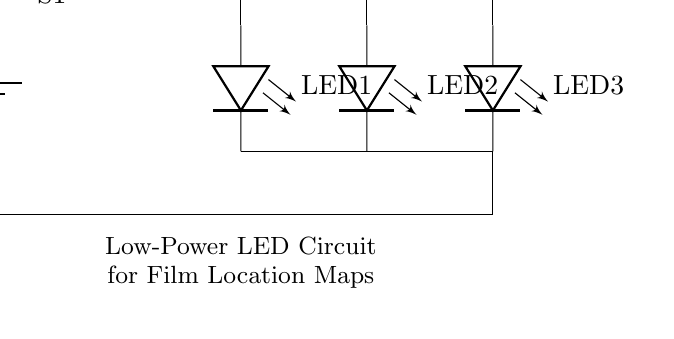What is the voltage of this circuit? The circuit is powered by a battery labeled as 3V, which indicates the potential difference supplied to the entire circuit.
Answer: 3V What is the purpose of the resistor in the circuit? The resistor, noted as 220 Ohms, is used to limit the current flowing through the LEDs, preventing them from burning out due to excessive current.
Answer: Current limiting How many LEDs are in this circuit? The diagram shows three LEDs labeled LED1, LED2, and LED3, indicating the total number of LEDs in the circuit.
Answer: Three What is the function of switch S1? Switch S1 allows the user to control the power to the circuit, turning it on or off, effectively managing the operation of the LEDs based on the switch's position.
Answer: Control power Which component connects all LEDs to ground? The ground connection is established through a line that connects the bottom terminals of the LEDs and ultimately connects to the battery's negative terminal, completing the circuit.
Answer: Ground connection What is the circuit type shown? The circuit is classified as a low-power LED lighting circuit, designed specifically for illuminating purposes, as indicated by the labels on the diagram.
Answer: Low-power LED circuit 